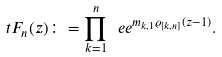<formula> <loc_0><loc_0><loc_500><loc_500>\ t F _ { n } ( z ) \colon = \prod _ { k = 1 } ^ { n } \ e e ^ { m _ { k , 1 } \varrho _ { [ k , n ] } ( z - 1 ) } .</formula> 